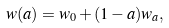<formula> <loc_0><loc_0><loc_500><loc_500>w ( a ) = w _ { 0 } + ( 1 - a ) w _ { a } ,</formula> 